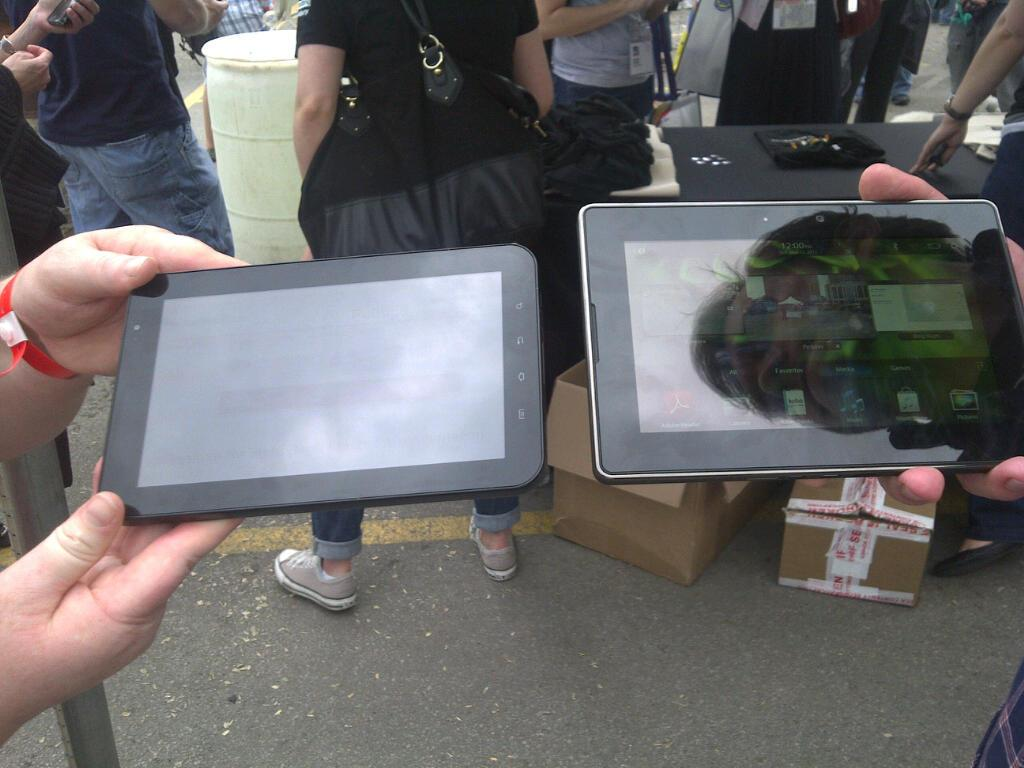How many people are in the image? There are two persons in the image. What are the two persons holding in their hands? The two persons are holding a tab in their hands. What can be seen in the background of the image? There are people, wooden boxes, a table, and other objects in the background of the image. What type of unit is being measured by the rose in the image? There is no rose present in the image, and therefore no unit measurement can be observed. 